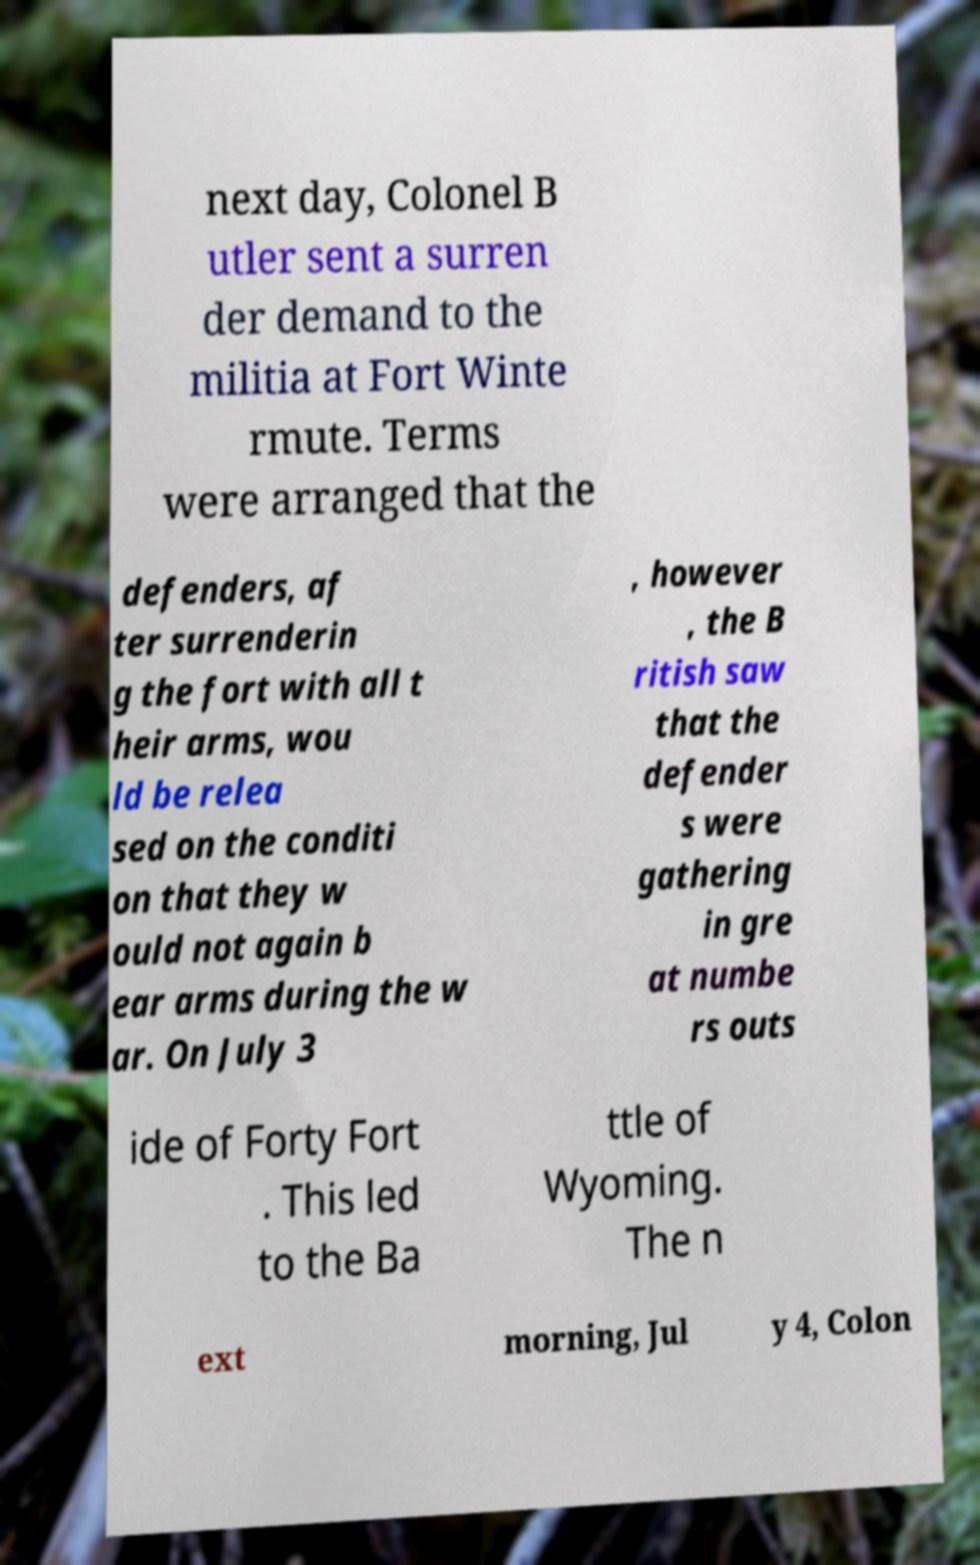Can you read and provide the text displayed in the image?This photo seems to have some interesting text. Can you extract and type it out for me? next day, Colonel B utler sent a surren der demand to the militia at Fort Winte rmute. Terms were arranged that the defenders, af ter surrenderin g the fort with all t heir arms, wou ld be relea sed on the conditi on that they w ould not again b ear arms during the w ar. On July 3 , however , the B ritish saw that the defender s were gathering in gre at numbe rs outs ide of Forty Fort . This led to the Ba ttle of Wyoming. The n ext morning, Jul y 4, Colon 